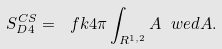Convert formula to latex. <formula><loc_0><loc_0><loc_500><loc_500>S ^ { C S } _ { D 4 } = \ f { k } { 4 \pi } \int _ { R ^ { 1 , 2 } } A \ w e d A .</formula> 